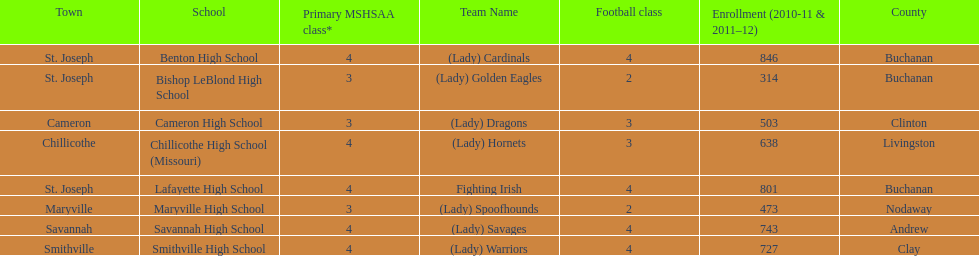Parse the full table. {'header': ['Town', 'School', 'Primary MSHSAA class*', 'Team Name', 'Football class', 'Enrollment (2010-11 & 2011–12)', 'County'], 'rows': [['St. Joseph', 'Benton High School', '4', '(Lady) Cardinals', '4', '846', 'Buchanan'], ['St. Joseph', 'Bishop LeBlond High School', '3', '(Lady) Golden Eagles', '2', '314', 'Buchanan'], ['Cameron', 'Cameron High School', '3', '(Lady) Dragons', '3', '503', 'Clinton'], ['Chillicothe', 'Chillicothe High School (Missouri)', '4', '(Lady) Hornets', '3', '638', 'Livingston'], ['St. Joseph', 'Lafayette High School', '4', 'Fighting Irish', '4', '801', 'Buchanan'], ['Maryville', 'Maryville High School', '3', '(Lady) Spoofhounds', '2', '473', 'Nodaway'], ['Savannah', 'Savannah High School', '4', '(Lady) Savages', '4', '743', 'Andrew'], ['Smithville', 'Smithville High School', '4', '(Lady) Warriors', '4', '727', 'Clay']]} What are all of the schools? Benton High School, Bishop LeBlond High School, Cameron High School, Chillicothe High School (Missouri), Lafayette High School, Maryville High School, Savannah High School, Smithville High School. How many football classes do they have? 4, 2, 3, 3, 4, 2, 4, 4. What about their enrollment? 846, 314, 503, 638, 801, 473, 743, 727. Which schools have 3 football classes? Cameron High School, Chillicothe High School (Missouri). And of those schools, which has 638 students? Chillicothe High School (Missouri). 